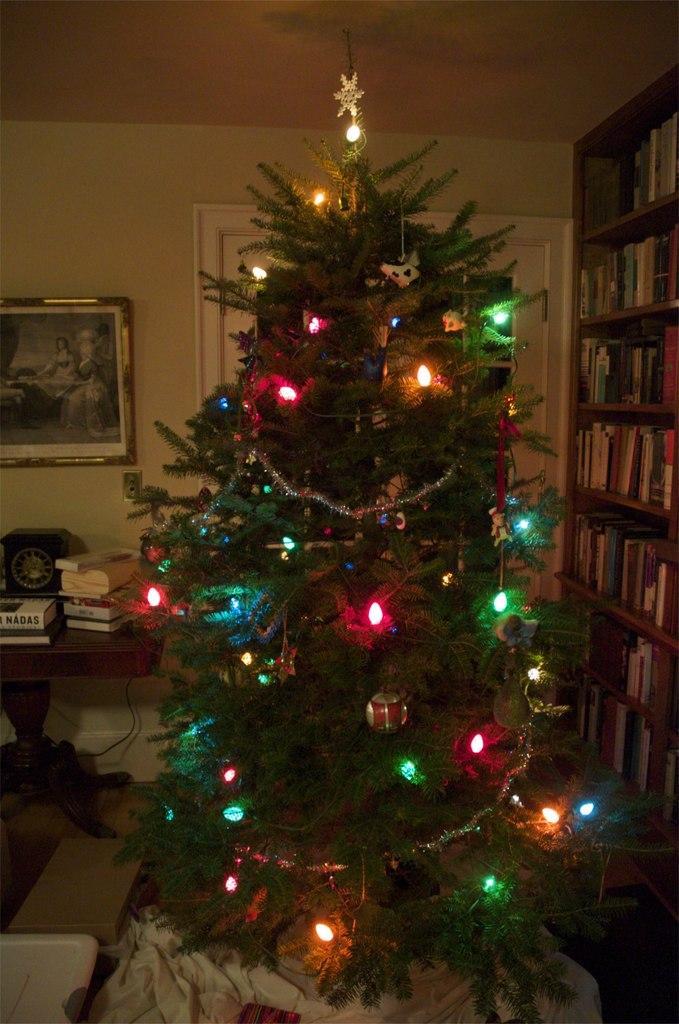Describe this image in one or two sentences. In this picture we can see Christmas tree, beside that there is a table. On the table we can see books. On the left there is a painting which is near to the door. On the right we can see many books which are arranged in wooden rack. 